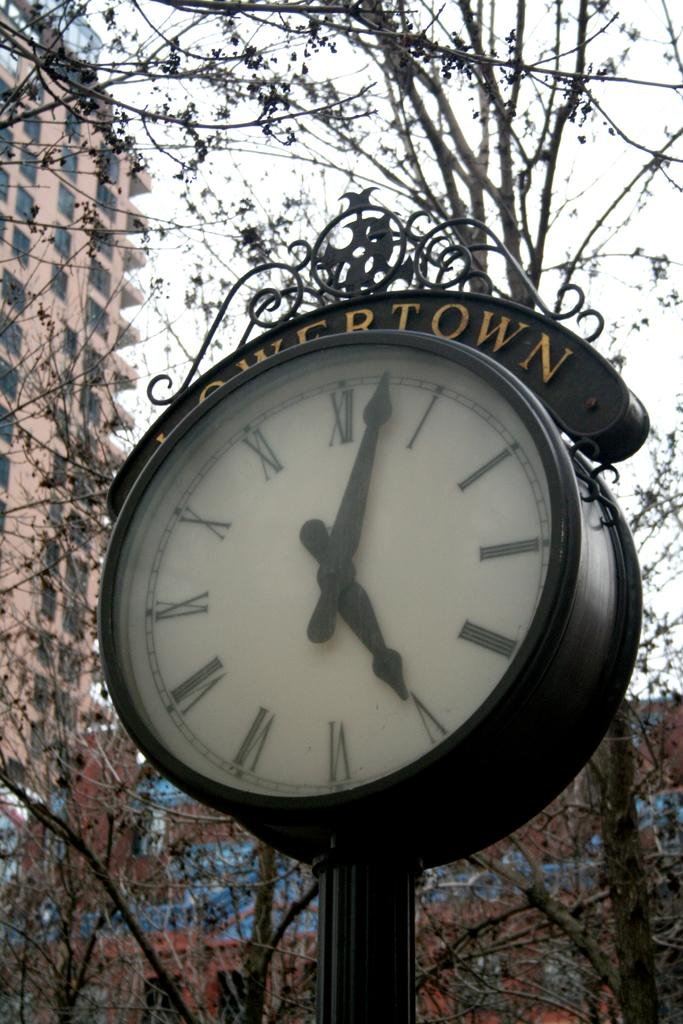<image>
Provide a brief description of the given image. Black clock with the words "Lowertown" on the top. 